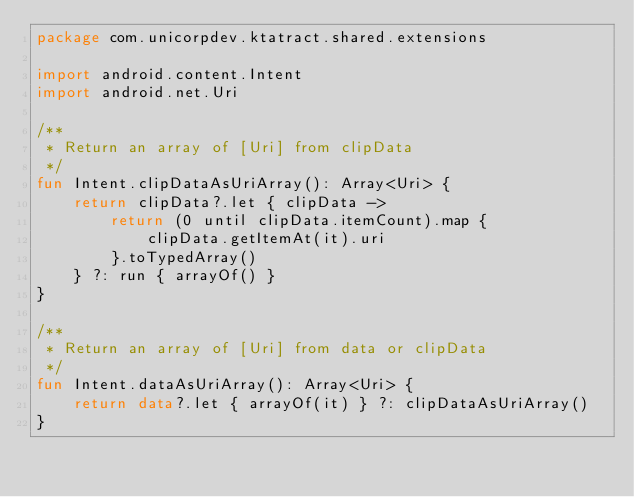<code> <loc_0><loc_0><loc_500><loc_500><_Kotlin_>package com.unicorpdev.ktatract.shared.extensions

import android.content.Intent
import android.net.Uri

/**
 * Return an array of [Uri] from clipData
 */
fun Intent.clipDataAsUriArray(): Array<Uri> {
    return clipData?.let { clipData ->
        return (0 until clipData.itemCount).map {
            clipData.getItemAt(it).uri
        }.toTypedArray()
    } ?: run { arrayOf() }
}

/**
 * Return an array of [Uri] from data or clipData
 */
fun Intent.dataAsUriArray(): Array<Uri> {
    return data?.let { arrayOf(it) } ?: clipDataAsUriArray()
}</code> 